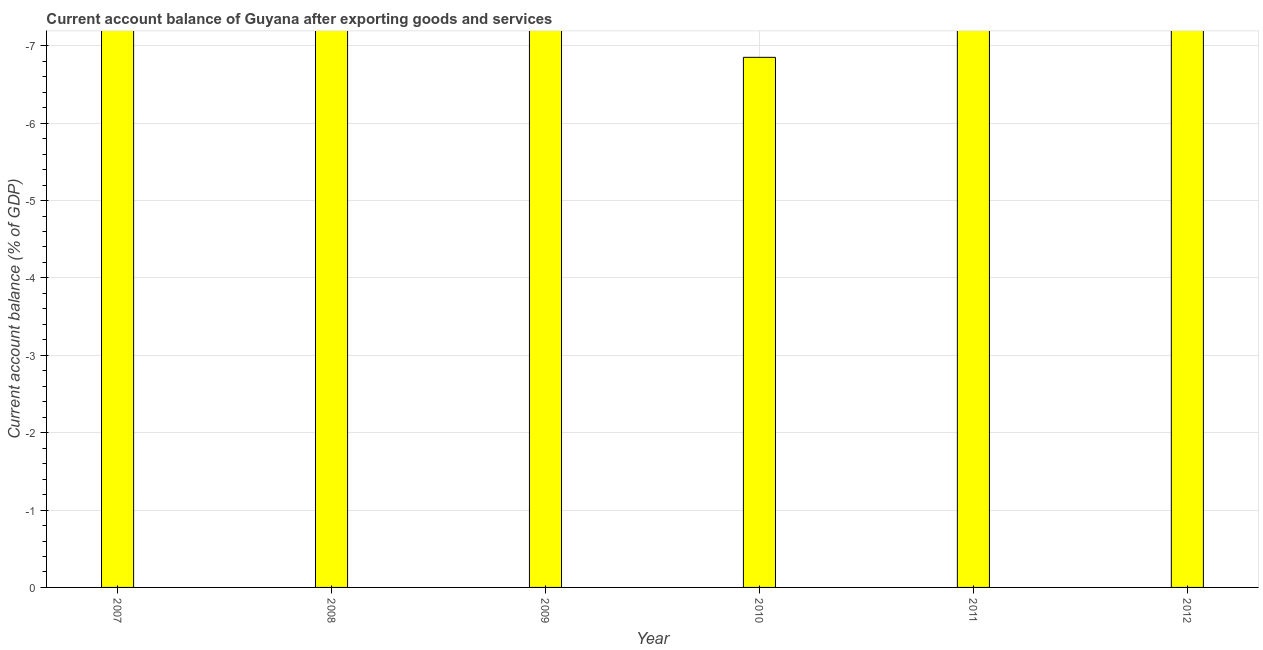Does the graph contain any zero values?
Provide a short and direct response. Yes. What is the title of the graph?
Offer a terse response. Current account balance of Guyana after exporting goods and services. What is the label or title of the X-axis?
Your answer should be very brief. Year. What is the label or title of the Y-axis?
Your response must be concise. Current account balance (% of GDP). What is the current account balance in 2007?
Your answer should be compact. 0. Across all years, what is the minimum current account balance?
Offer a very short reply. 0. What is the average current account balance per year?
Make the answer very short. 0. In how many years, is the current account balance greater than -0.4 %?
Your answer should be compact. 0. How many bars are there?
Offer a very short reply. 0. Are the values on the major ticks of Y-axis written in scientific E-notation?
Your answer should be very brief. No. What is the Current account balance (% of GDP) in 2009?
Offer a very short reply. 0. 